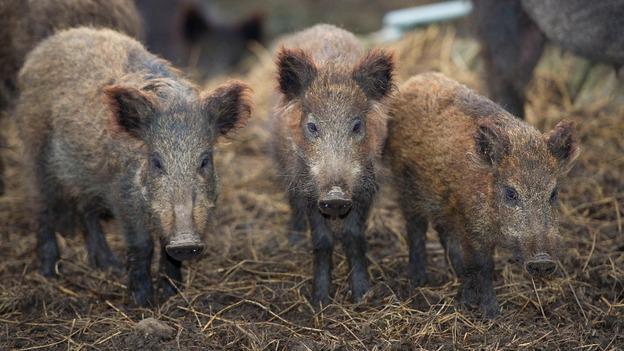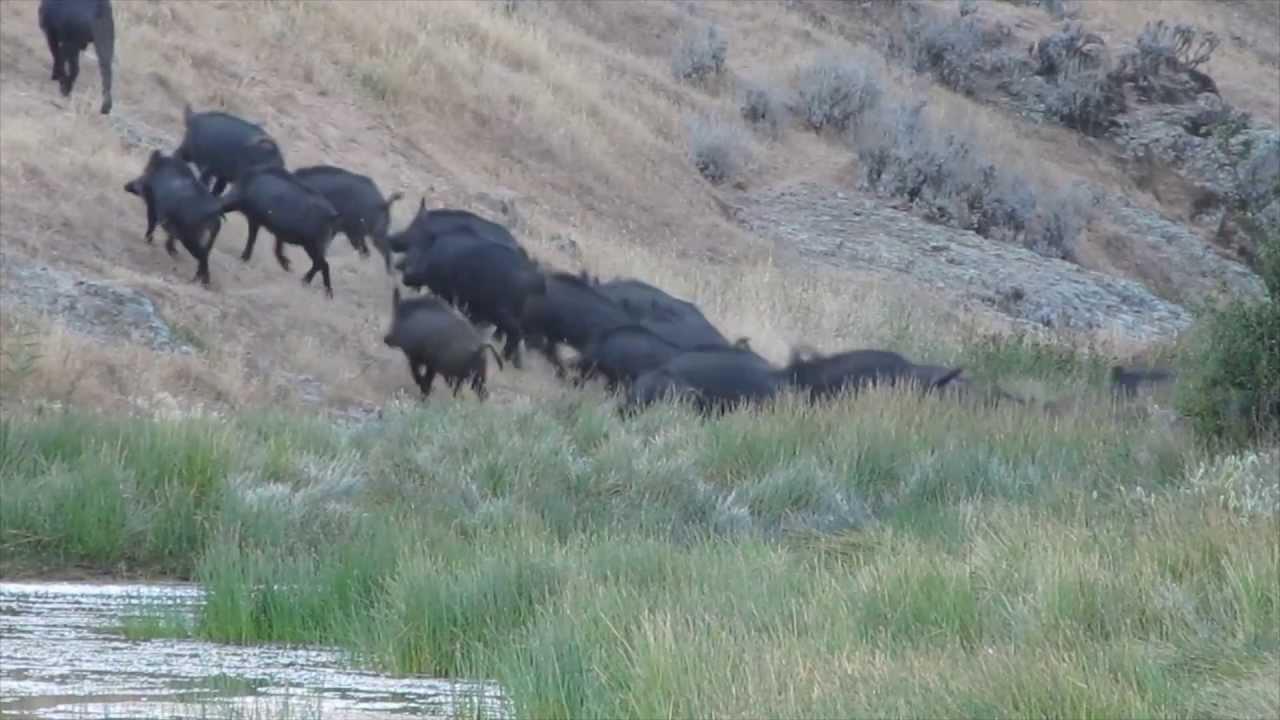The first image is the image on the left, the second image is the image on the right. Considering the images on both sides, is "One wild pig is standing in the grass in the image on the left." valid? Answer yes or no. No. 